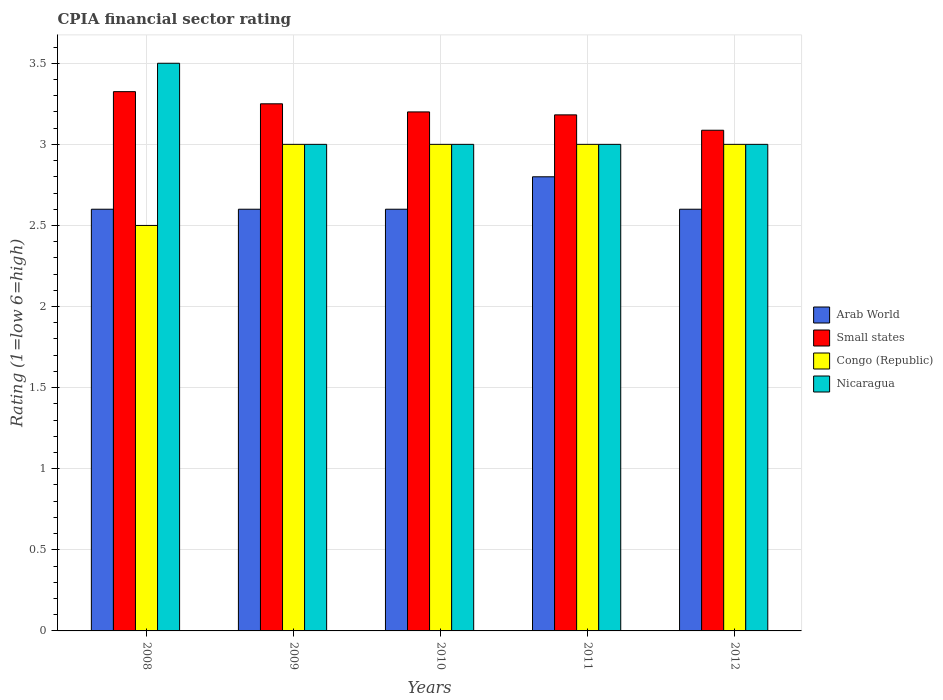Are the number of bars per tick equal to the number of legend labels?
Offer a very short reply. Yes. How many bars are there on the 2nd tick from the right?
Give a very brief answer. 4. What is the label of the 1st group of bars from the left?
Give a very brief answer. 2008. In how many cases, is the number of bars for a given year not equal to the number of legend labels?
Offer a terse response. 0. Across all years, what is the maximum CPIA rating in Congo (Republic)?
Your response must be concise. 3. Across all years, what is the minimum CPIA rating in Arab World?
Offer a terse response. 2.6. In which year was the CPIA rating in Arab World maximum?
Your answer should be compact. 2011. What is the total CPIA rating in Small states in the graph?
Keep it short and to the point. 16.04. What is the difference between the CPIA rating in Arab World in 2008 and that in 2012?
Provide a short and direct response. 0. What is the difference between the CPIA rating in Nicaragua in 2009 and the CPIA rating in Arab World in 2012?
Your response must be concise. 0.4. In the year 2010, what is the difference between the CPIA rating in Arab World and CPIA rating in Nicaragua?
Offer a very short reply. -0.4. In how many years, is the CPIA rating in Arab World greater than 0.7?
Ensure brevity in your answer.  5. What is the ratio of the CPIA rating in Nicaragua in 2008 to that in 2010?
Provide a short and direct response. 1.17. Is the difference between the CPIA rating in Arab World in 2008 and 2012 greater than the difference between the CPIA rating in Nicaragua in 2008 and 2012?
Your response must be concise. No. What is the difference between the highest and the second highest CPIA rating in Arab World?
Provide a succinct answer. 0.2. What is the difference between the highest and the lowest CPIA rating in Congo (Republic)?
Offer a terse response. 0.5. Is it the case that in every year, the sum of the CPIA rating in Congo (Republic) and CPIA rating in Nicaragua is greater than the sum of CPIA rating in Small states and CPIA rating in Arab World?
Provide a succinct answer. No. What does the 2nd bar from the left in 2012 represents?
Keep it short and to the point. Small states. What does the 2nd bar from the right in 2010 represents?
Offer a terse response. Congo (Republic). Is it the case that in every year, the sum of the CPIA rating in Arab World and CPIA rating in Small states is greater than the CPIA rating in Nicaragua?
Make the answer very short. Yes. What is the difference between two consecutive major ticks on the Y-axis?
Your answer should be compact. 0.5. Are the values on the major ticks of Y-axis written in scientific E-notation?
Offer a terse response. No. How many legend labels are there?
Make the answer very short. 4. What is the title of the graph?
Your answer should be compact. CPIA financial sector rating. What is the label or title of the X-axis?
Offer a terse response. Years. What is the Rating (1=low 6=high) in Arab World in 2008?
Keep it short and to the point. 2.6. What is the Rating (1=low 6=high) of Small states in 2008?
Your answer should be very brief. 3.33. What is the Rating (1=low 6=high) in Congo (Republic) in 2008?
Make the answer very short. 2.5. What is the Rating (1=low 6=high) in Nicaragua in 2008?
Your response must be concise. 3.5. What is the Rating (1=low 6=high) in Small states in 2009?
Offer a very short reply. 3.25. What is the Rating (1=low 6=high) of Nicaragua in 2009?
Ensure brevity in your answer.  3. What is the Rating (1=low 6=high) of Arab World in 2010?
Your answer should be very brief. 2.6. What is the Rating (1=low 6=high) of Nicaragua in 2010?
Offer a terse response. 3. What is the Rating (1=low 6=high) in Small states in 2011?
Offer a terse response. 3.18. What is the Rating (1=low 6=high) in Congo (Republic) in 2011?
Your response must be concise. 3. What is the Rating (1=low 6=high) of Nicaragua in 2011?
Your answer should be compact. 3. What is the Rating (1=low 6=high) of Small states in 2012?
Your answer should be compact. 3.09. What is the Rating (1=low 6=high) in Congo (Republic) in 2012?
Offer a very short reply. 3. Across all years, what is the maximum Rating (1=low 6=high) of Arab World?
Keep it short and to the point. 2.8. Across all years, what is the maximum Rating (1=low 6=high) in Small states?
Give a very brief answer. 3.33. Across all years, what is the maximum Rating (1=low 6=high) of Congo (Republic)?
Provide a short and direct response. 3. Across all years, what is the minimum Rating (1=low 6=high) in Small states?
Ensure brevity in your answer.  3.09. Across all years, what is the minimum Rating (1=low 6=high) in Congo (Republic)?
Your answer should be compact. 2.5. Across all years, what is the minimum Rating (1=low 6=high) in Nicaragua?
Your answer should be very brief. 3. What is the total Rating (1=low 6=high) of Arab World in the graph?
Provide a short and direct response. 13.2. What is the total Rating (1=low 6=high) in Small states in the graph?
Ensure brevity in your answer.  16.04. What is the total Rating (1=low 6=high) of Congo (Republic) in the graph?
Ensure brevity in your answer.  14.5. What is the total Rating (1=low 6=high) in Nicaragua in the graph?
Your answer should be compact. 15.5. What is the difference between the Rating (1=low 6=high) in Arab World in 2008 and that in 2009?
Provide a short and direct response. 0. What is the difference between the Rating (1=low 6=high) of Small states in 2008 and that in 2009?
Your answer should be compact. 0.07. What is the difference between the Rating (1=low 6=high) of Congo (Republic) in 2008 and that in 2009?
Provide a short and direct response. -0.5. What is the difference between the Rating (1=low 6=high) of Arab World in 2008 and that in 2010?
Your answer should be compact. 0. What is the difference between the Rating (1=low 6=high) in Small states in 2008 and that in 2010?
Your response must be concise. 0.12. What is the difference between the Rating (1=low 6=high) of Congo (Republic) in 2008 and that in 2010?
Provide a short and direct response. -0.5. What is the difference between the Rating (1=low 6=high) in Small states in 2008 and that in 2011?
Offer a very short reply. 0.14. What is the difference between the Rating (1=low 6=high) of Congo (Republic) in 2008 and that in 2011?
Your answer should be compact. -0.5. What is the difference between the Rating (1=low 6=high) in Nicaragua in 2008 and that in 2011?
Offer a terse response. 0.5. What is the difference between the Rating (1=low 6=high) in Small states in 2008 and that in 2012?
Provide a short and direct response. 0.24. What is the difference between the Rating (1=low 6=high) in Nicaragua in 2008 and that in 2012?
Offer a very short reply. 0.5. What is the difference between the Rating (1=low 6=high) in Small states in 2009 and that in 2010?
Make the answer very short. 0.05. What is the difference between the Rating (1=low 6=high) of Nicaragua in 2009 and that in 2010?
Your response must be concise. 0. What is the difference between the Rating (1=low 6=high) in Small states in 2009 and that in 2011?
Provide a short and direct response. 0.07. What is the difference between the Rating (1=low 6=high) in Congo (Republic) in 2009 and that in 2011?
Offer a very short reply. 0. What is the difference between the Rating (1=low 6=high) in Nicaragua in 2009 and that in 2011?
Your response must be concise. 0. What is the difference between the Rating (1=low 6=high) in Small states in 2009 and that in 2012?
Your response must be concise. 0.16. What is the difference between the Rating (1=low 6=high) in Arab World in 2010 and that in 2011?
Provide a succinct answer. -0.2. What is the difference between the Rating (1=low 6=high) in Small states in 2010 and that in 2011?
Give a very brief answer. 0.02. What is the difference between the Rating (1=low 6=high) in Nicaragua in 2010 and that in 2011?
Ensure brevity in your answer.  0. What is the difference between the Rating (1=low 6=high) in Arab World in 2010 and that in 2012?
Your response must be concise. 0. What is the difference between the Rating (1=low 6=high) in Small states in 2010 and that in 2012?
Give a very brief answer. 0.11. What is the difference between the Rating (1=low 6=high) of Congo (Republic) in 2010 and that in 2012?
Offer a very short reply. 0. What is the difference between the Rating (1=low 6=high) of Nicaragua in 2010 and that in 2012?
Provide a short and direct response. 0. What is the difference between the Rating (1=low 6=high) of Small states in 2011 and that in 2012?
Keep it short and to the point. 0.09. What is the difference between the Rating (1=low 6=high) in Arab World in 2008 and the Rating (1=low 6=high) in Small states in 2009?
Keep it short and to the point. -0.65. What is the difference between the Rating (1=low 6=high) of Arab World in 2008 and the Rating (1=low 6=high) of Congo (Republic) in 2009?
Offer a terse response. -0.4. What is the difference between the Rating (1=low 6=high) in Small states in 2008 and the Rating (1=low 6=high) in Congo (Republic) in 2009?
Your answer should be compact. 0.33. What is the difference between the Rating (1=low 6=high) in Small states in 2008 and the Rating (1=low 6=high) in Nicaragua in 2009?
Make the answer very short. 0.33. What is the difference between the Rating (1=low 6=high) in Arab World in 2008 and the Rating (1=low 6=high) in Small states in 2010?
Offer a terse response. -0.6. What is the difference between the Rating (1=low 6=high) of Arab World in 2008 and the Rating (1=low 6=high) of Nicaragua in 2010?
Your answer should be very brief. -0.4. What is the difference between the Rating (1=low 6=high) of Small states in 2008 and the Rating (1=low 6=high) of Congo (Republic) in 2010?
Provide a short and direct response. 0.33. What is the difference between the Rating (1=low 6=high) of Small states in 2008 and the Rating (1=low 6=high) of Nicaragua in 2010?
Your response must be concise. 0.33. What is the difference between the Rating (1=low 6=high) in Arab World in 2008 and the Rating (1=low 6=high) in Small states in 2011?
Give a very brief answer. -0.58. What is the difference between the Rating (1=low 6=high) in Arab World in 2008 and the Rating (1=low 6=high) in Congo (Republic) in 2011?
Offer a terse response. -0.4. What is the difference between the Rating (1=low 6=high) of Arab World in 2008 and the Rating (1=low 6=high) of Nicaragua in 2011?
Give a very brief answer. -0.4. What is the difference between the Rating (1=low 6=high) of Small states in 2008 and the Rating (1=low 6=high) of Congo (Republic) in 2011?
Give a very brief answer. 0.33. What is the difference between the Rating (1=low 6=high) in Small states in 2008 and the Rating (1=low 6=high) in Nicaragua in 2011?
Offer a very short reply. 0.33. What is the difference between the Rating (1=low 6=high) in Arab World in 2008 and the Rating (1=low 6=high) in Small states in 2012?
Ensure brevity in your answer.  -0.49. What is the difference between the Rating (1=low 6=high) in Small states in 2008 and the Rating (1=low 6=high) in Congo (Republic) in 2012?
Your answer should be very brief. 0.33. What is the difference between the Rating (1=low 6=high) of Small states in 2008 and the Rating (1=low 6=high) of Nicaragua in 2012?
Provide a short and direct response. 0.33. What is the difference between the Rating (1=low 6=high) in Arab World in 2009 and the Rating (1=low 6=high) in Small states in 2010?
Your answer should be compact. -0.6. What is the difference between the Rating (1=low 6=high) in Small states in 2009 and the Rating (1=low 6=high) in Nicaragua in 2010?
Offer a very short reply. 0.25. What is the difference between the Rating (1=low 6=high) of Arab World in 2009 and the Rating (1=low 6=high) of Small states in 2011?
Offer a very short reply. -0.58. What is the difference between the Rating (1=low 6=high) of Arab World in 2009 and the Rating (1=low 6=high) of Congo (Republic) in 2011?
Make the answer very short. -0.4. What is the difference between the Rating (1=low 6=high) in Small states in 2009 and the Rating (1=low 6=high) in Congo (Republic) in 2011?
Give a very brief answer. 0.25. What is the difference between the Rating (1=low 6=high) in Small states in 2009 and the Rating (1=low 6=high) in Nicaragua in 2011?
Your answer should be compact. 0.25. What is the difference between the Rating (1=low 6=high) in Arab World in 2009 and the Rating (1=low 6=high) in Small states in 2012?
Offer a terse response. -0.49. What is the difference between the Rating (1=low 6=high) in Arab World in 2009 and the Rating (1=low 6=high) in Congo (Republic) in 2012?
Offer a very short reply. -0.4. What is the difference between the Rating (1=low 6=high) of Arab World in 2009 and the Rating (1=low 6=high) of Nicaragua in 2012?
Your response must be concise. -0.4. What is the difference between the Rating (1=low 6=high) in Small states in 2009 and the Rating (1=low 6=high) in Congo (Republic) in 2012?
Provide a succinct answer. 0.25. What is the difference between the Rating (1=low 6=high) of Small states in 2009 and the Rating (1=low 6=high) of Nicaragua in 2012?
Give a very brief answer. 0.25. What is the difference between the Rating (1=low 6=high) of Arab World in 2010 and the Rating (1=low 6=high) of Small states in 2011?
Your response must be concise. -0.58. What is the difference between the Rating (1=low 6=high) in Arab World in 2010 and the Rating (1=low 6=high) in Nicaragua in 2011?
Ensure brevity in your answer.  -0.4. What is the difference between the Rating (1=low 6=high) in Small states in 2010 and the Rating (1=low 6=high) in Congo (Republic) in 2011?
Keep it short and to the point. 0.2. What is the difference between the Rating (1=low 6=high) of Congo (Republic) in 2010 and the Rating (1=low 6=high) of Nicaragua in 2011?
Keep it short and to the point. 0. What is the difference between the Rating (1=low 6=high) in Arab World in 2010 and the Rating (1=low 6=high) in Small states in 2012?
Keep it short and to the point. -0.49. What is the difference between the Rating (1=low 6=high) of Arab World in 2011 and the Rating (1=low 6=high) of Small states in 2012?
Your answer should be compact. -0.29. What is the difference between the Rating (1=low 6=high) of Arab World in 2011 and the Rating (1=low 6=high) of Nicaragua in 2012?
Provide a succinct answer. -0.2. What is the difference between the Rating (1=low 6=high) of Small states in 2011 and the Rating (1=low 6=high) of Congo (Republic) in 2012?
Your answer should be very brief. 0.18. What is the difference between the Rating (1=low 6=high) in Small states in 2011 and the Rating (1=low 6=high) in Nicaragua in 2012?
Make the answer very short. 0.18. What is the average Rating (1=low 6=high) in Arab World per year?
Your response must be concise. 2.64. What is the average Rating (1=low 6=high) of Small states per year?
Keep it short and to the point. 3.21. What is the average Rating (1=low 6=high) in Nicaragua per year?
Make the answer very short. 3.1. In the year 2008, what is the difference between the Rating (1=low 6=high) of Arab World and Rating (1=low 6=high) of Small states?
Provide a short and direct response. -0.72. In the year 2008, what is the difference between the Rating (1=low 6=high) in Arab World and Rating (1=low 6=high) in Congo (Republic)?
Provide a succinct answer. 0.1. In the year 2008, what is the difference between the Rating (1=low 6=high) of Small states and Rating (1=low 6=high) of Congo (Republic)?
Give a very brief answer. 0.82. In the year 2008, what is the difference between the Rating (1=low 6=high) of Small states and Rating (1=low 6=high) of Nicaragua?
Provide a short and direct response. -0.17. In the year 2009, what is the difference between the Rating (1=low 6=high) of Arab World and Rating (1=low 6=high) of Small states?
Provide a short and direct response. -0.65. In the year 2009, what is the difference between the Rating (1=low 6=high) of Arab World and Rating (1=low 6=high) of Congo (Republic)?
Offer a terse response. -0.4. In the year 2009, what is the difference between the Rating (1=low 6=high) in Small states and Rating (1=low 6=high) in Nicaragua?
Your response must be concise. 0.25. In the year 2009, what is the difference between the Rating (1=low 6=high) in Congo (Republic) and Rating (1=low 6=high) in Nicaragua?
Make the answer very short. 0. In the year 2010, what is the difference between the Rating (1=low 6=high) in Arab World and Rating (1=low 6=high) in Small states?
Keep it short and to the point. -0.6. In the year 2010, what is the difference between the Rating (1=low 6=high) of Arab World and Rating (1=low 6=high) of Congo (Republic)?
Provide a short and direct response. -0.4. In the year 2010, what is the difference between the Rating (1=low 6=high) of Arab World and Rating (1=low 6=high) of Nicaragua?
Offer a very short reply. -0.4. In the year 2010, what is the difference between the Rating (1=low 6=high) of Small states and Rating (1=low 6=high) of Congo (Republic)?
Provide a short and direct response. 0.2. In the year 2011, what is the difference between the Rating (1=low 6=high) of Arab World and Rating (1=low 6=high) of Small states?
Make the answer very short. -0.38. In the year 2011, what is the difference between the Rating (1=low 6=high) in Arab World and Rating (1=low 6=high) in Nicaragua?
Ensure brevity in your answer.  -0.2. In the year 2011, what is the difference between the Rating (1=low 6=high) of Small states and Rating (1=low 6=high) of Congo (Republic)?
Offer a terse response. 0.18. In the year 2011, what is the difference between the Rating (1=low 6=high) of Small states and Rating (1=low 6=high) of Nicaragua?
Offer a very short reply. 0.18. In the year 2011, what is the difference between the Rating (1=low 6=high) of Congo (Republic) and Rating (1=low 6=high) of Nicaragua?
Your answer should be very brief. 0. In the year 2012, what is the difference between the Rating (1=low 6=high) in Arab World and Rating (1=low 6=high) in Small states?
Offer a very short reply. -0.49. In the year 2012, what is the difference between the Rating (1=low 6=high) of Arab World and Rating (1=low 6=high) of Nicaragua?
Make the answer very short. -0.4. In the year 2012, what is the difference between the Rating (1=low 6=high) in Small states and Rating (1=low 6=high) in Congo (Republic)?
Make the answer very short. 0.09. In the year 2012, what is the difference between the Rating (1=low 6=high) in Small states and Rating (1=low 6=high) in Nicaragua?
Offer a terse response. 0.09. In the year 2012, what is the difference between the Rating (1=low 6=high) of Congo (Republic) and Rating (1=low 6=high) of Nicaragua?
Your answer should be compact. 0. What is the ratio of the Rating (1=low 6=high) in Arab World in 2008 to that in 2009?
Your answer should be compact. 1. What is the ratio of the Rating (1=low 6=high) of Small states in 2008 to that in 2009?
Your answer should be compact. 1.02. What is the ratio of the Rating (1=low 6=high) of Small states in 2008 to that in 2010?
Offer a terse response. 1.04. What is the ratio of the Rating (1=low 6=high) of Congo (Republic) in 2008 to that in 2010?
Your response must be concise. 0.83. What is the ratio of the Rating (1=low 6=high) in Nicaragua in 2008 to that in 2010?
Provide a short and direct response. 1.17. What is the ratio of the Rating (1=low 6=high) in Small states in 2008 to that in 2011?
Give a very brief answer. 1.04. What is the ratio of the Rating (1=low 6=high) in Congo (Republic) in 2008 to that in 2011?
Offer a terse response. 0.83. What is the ratio of the Rating (1=low 6=high) of Arab World in 2008 to that in 2012?
Keep it short and to the point. 1. What is the ratio of the Rating (1=low 6=high) in Small states in 2008 to that in 2012?
Your answer should be very brief. 1.08. What is the ratio of the Rating (1=low 6=high) in Nicaragua in 2008 to that in 2012?
Ensure brevity in your answer.  1.17. What is the ratio of the Rating (1=low 6=high) of Arab World in 2009 to that in 2010?
Provide a short and direct response. 1. What is the ratio of the Rating (1=low 6=high) of Small states in 2009 to that in 2010?
Offer a terse response. 1.02. What is the ratio of the Rating (1=low 6=high) of Nicaragua in 2009 to that in 2010?
Your answer should be compact. 1. What is the ratio of the Rating (1=low 6=high) of Arab World in 2009 to that in 2011?
Make the answer very short. 0.93. What is the ratio of the Rating (1=low 6=high) in Small states in 2009 to that in 2011?
Offer a terse response. 1.02. What is the ratio of the Rating (1=low 6=high) of Congo (Republic) in 2009 to that in 2011?
Offer a very short reply. 1. What is the ratio of the Rating (1=low 6=high) in Small states in 2009 to that in 2012?
Offer a terse response. 1.05. What is the ratio of the Rating (1=low 6=high) in Arab World in 2010 to that in 2011?
Offer a terse response. 0.93. What is the ratio of the Rating (1=low 6=high) of Nicaragua in 2010 to that in 2011?
Your answer should be very brief. 1. What is the ratio of the Rating (1=low 6=high) in Arab World in 2010 to that in 2012?
Your response must be concise. 1. What is the ratio of the Rating (1=low 6=high) in Small states in 2010 to that in 2012?
Make the answer very short. 1.04. What is the ratio of the Rating (1=low 6=high) of Nicaragua in 2010 to that in 2012?
Your answer should be compact. 1. What is the ratio of the Rating (1=low 6=high) in Small states in 2011 to that in 2012?
Provide a short and direct response. 1.03. What is the ratio of the Rating (1=low 6=high) of Nicaragua in 2011 to that in 2012?
Your answer should be compact. 1. What is the difference between the highest and the second highest Rating (1=low 6=high) in Small states?
Your response must be concise. 0.07. What is the difference between the highest and the second highest Rating (1=low 6=high) in Congo (Republic)?
Offer a terse response. 0. What is the difference between the highest and the second highest Rating (1=low 6=high) of Nicaragua?
Offer a terse response. 0.5. What is the difference between the highest and the lowest Rating (1=low 6=high) of Arab World?
Ensure brevity in your answer.  0.2. What is the difference between the highest and the lowest Rating (1=low 6=high) in Small states?
Your answer should be compact. 0.24. What is the difference between the highest and the lowest Rating (1=low 6=high) in Congo (Republic)?
Ensure brevity in your answer.  0.5. What is the difference between the highest and the lowest Rating (1=low 6=high) in Nicaragua?
Your answer should be very brief. 0.5. 